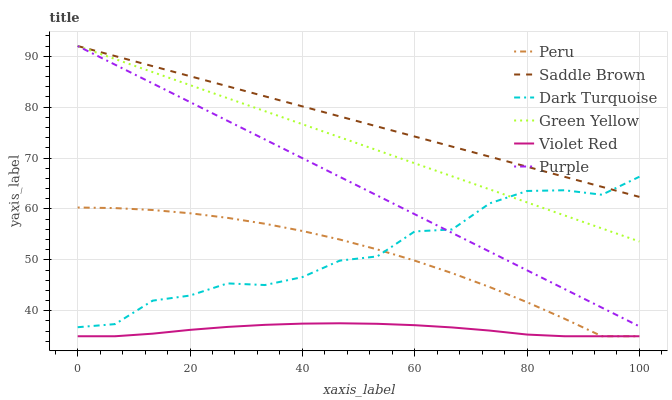Does Violet Red have the minimum area under the curve?
Answer yes or no. Yes. Does Saddle Brown have the maximum area under the curve?
Answer yes or no. Yes. Does Purple have the minimum area under the curve?
Answer yes or no. No. Does Purple have the maximum area under the curve?
Answer yes or no. No. Is Purple the smoothest?
Answer yes or no. Yes. Is Dark Turquoise the roughest?
Answer yes or no. Yes. Is Dark Turquoise the smoothest?
Answer yes or no. No. Is Purple the roughest?
Answer yes or no. No. Does Violet Red have the lowest value?
Answer yes or no. Yes. Does Purple have the lowest value?
Answer yes or no. No. Does Saddle Brown have the highest value?
Answer yes or no. Yes. Does Dark Turquoise have the highest value?
Answer yes or no. No. Is Violet Red less than Saddle Brown?
Answer yes or no. Yes. Is Saddle Brown greater than Violet Red?
Answer yes or no. Yes. Does Dark Turquoise intersect Peru?
Answer yes or no. Yes. Is Dark Turquoise less than Peru?
Answer yes or no. No. Is Dark Turquoise greater than Peru?
Answer yes or no. No. Does Violet Red intersect Saddle Brown?
Answer yes or no. No. 